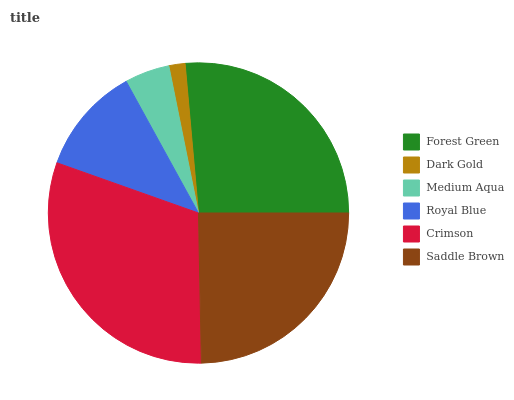Is Dark Gold the minimum?
Answer yes or no. Yes. Is Crimson the maximum?
Answer yes or no. Yes. Is Medium Aqua the minimum?
Answer yes or no. No. Is Medium Aqua the maximum?
Answer yes or no. No. Is Medium Aqua greater than Dark Gold?
Answer yes or no. Yes. Is Dark Gold less than Medium Aqua?
Answer yes or no. Yes. Is Dark Gold greater than Medium Aqua?
Answer yes or no. No. Is Medium Aqua less than Dark Gold?
Answer yes or no. No. Is Saddle Brown the high median?
Answer yes or no. Yes. Is Royal Blue the low median?
Answer yes or no. Yes. Is Crimson the high median?
Answer yes or no. No. Is Forest Green the low median?
Answer yes or no. No. 